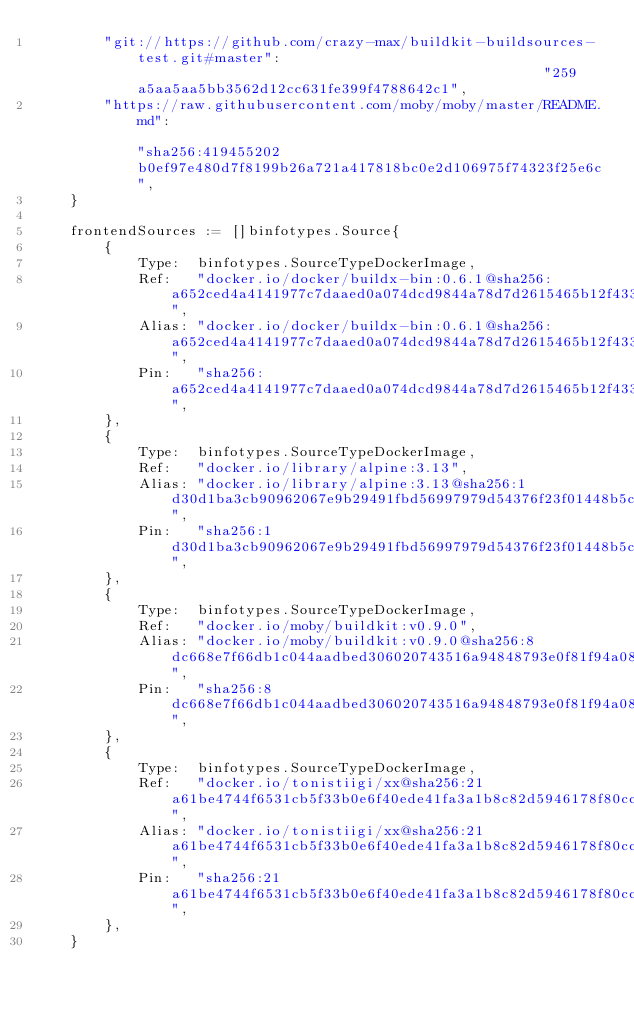Convert code to text. <code><loc_0><loc_0><loc_500><loc_500><_Go_>		"git://https://github.com/crazy-max/buildkit-buildsources-test.git#master":                                                 "259a5aa5aa5bb3562d12cc631fe399f4788642c1",
		"https://raw.githubusercontent.com/moby/moby/master/README.md":                                                             "sha256:419455202b0ef97e480d7f8199b26a721a417818bc0e2d106975f74323f25e6c",
	}

	frontendSources := []binfotypes.Source{
		{
			Type:  binfotypes.SourceTypeDockerImage,
			Ref:   "docker.io/docker/buildx-bin:0.6.1@sha256:a652ced4a4141977c7daaed0a074dcd9844a78d7d2615465b12f433ae6dd29f0",
			Alias: "docker.io/docker/buildx-bin:0.6.1@sha256:a652ced4a4141977c7daaed0a074dcd9844a78d7d2615465b12f433ae6dd29f0",
			Pin:   "sha256:a652ced4a4141977c7daaed0a074dcd9844a78d7d2615465b12f433ae6dd29f0",
		},
		{
			Type:  binfotypes.SourceTypeDockerImage,
			Ref:   "docker.io/library/alpine:3.13",
			Alias: "docker.io/library/alpine:3.13@sha256:1d30d1ba3cb90962067e9b29491fbd56997979d54376f23f01448b5c5cd8b462",
			Pin:   "sha256:1d30d1ba3cb90962067e9b29491fbd56997979d54376f23f01448b5c5cd8b462",
		},
		{
			Type:  binfotypes.SourceTypeDockerImage,
			Ref:   "docker.io/moby/buildkit:v0.9.0",
			Alias: "docker.io/moby/buildkit:v0.9.0@sha256:8dc668e7f66db1c044aadbed306020743516a94848793e0f81f94a087ee78cab",
			Pin:   "sha256:8dc668e7f66db1c044aadbed306020743516a94848793e0f81f94a087ee78cab",
		},
		{
			Type:  binfotypes.SourceTypeDockerImage,
			Ref:   "docker.io/tonistiigi/xx@sha256:21a61be4744f6531cb5f33b0e6f40ede41fa3a1b8c82d5946178f80cc84bfc04",
			Alias: "docker.io/tonistiigi/xx@sha256:21a61be4744f6531cb5f33b0e6f40ede41fa3a1b8c82d5946178f80cc84bfc04",
			Pin:   "sha256:21a61be4744f6531cb5f33b0e6f40ede41fa3a1b8c82d5946178f80cc84bfc04",
		},
	}
</code> 